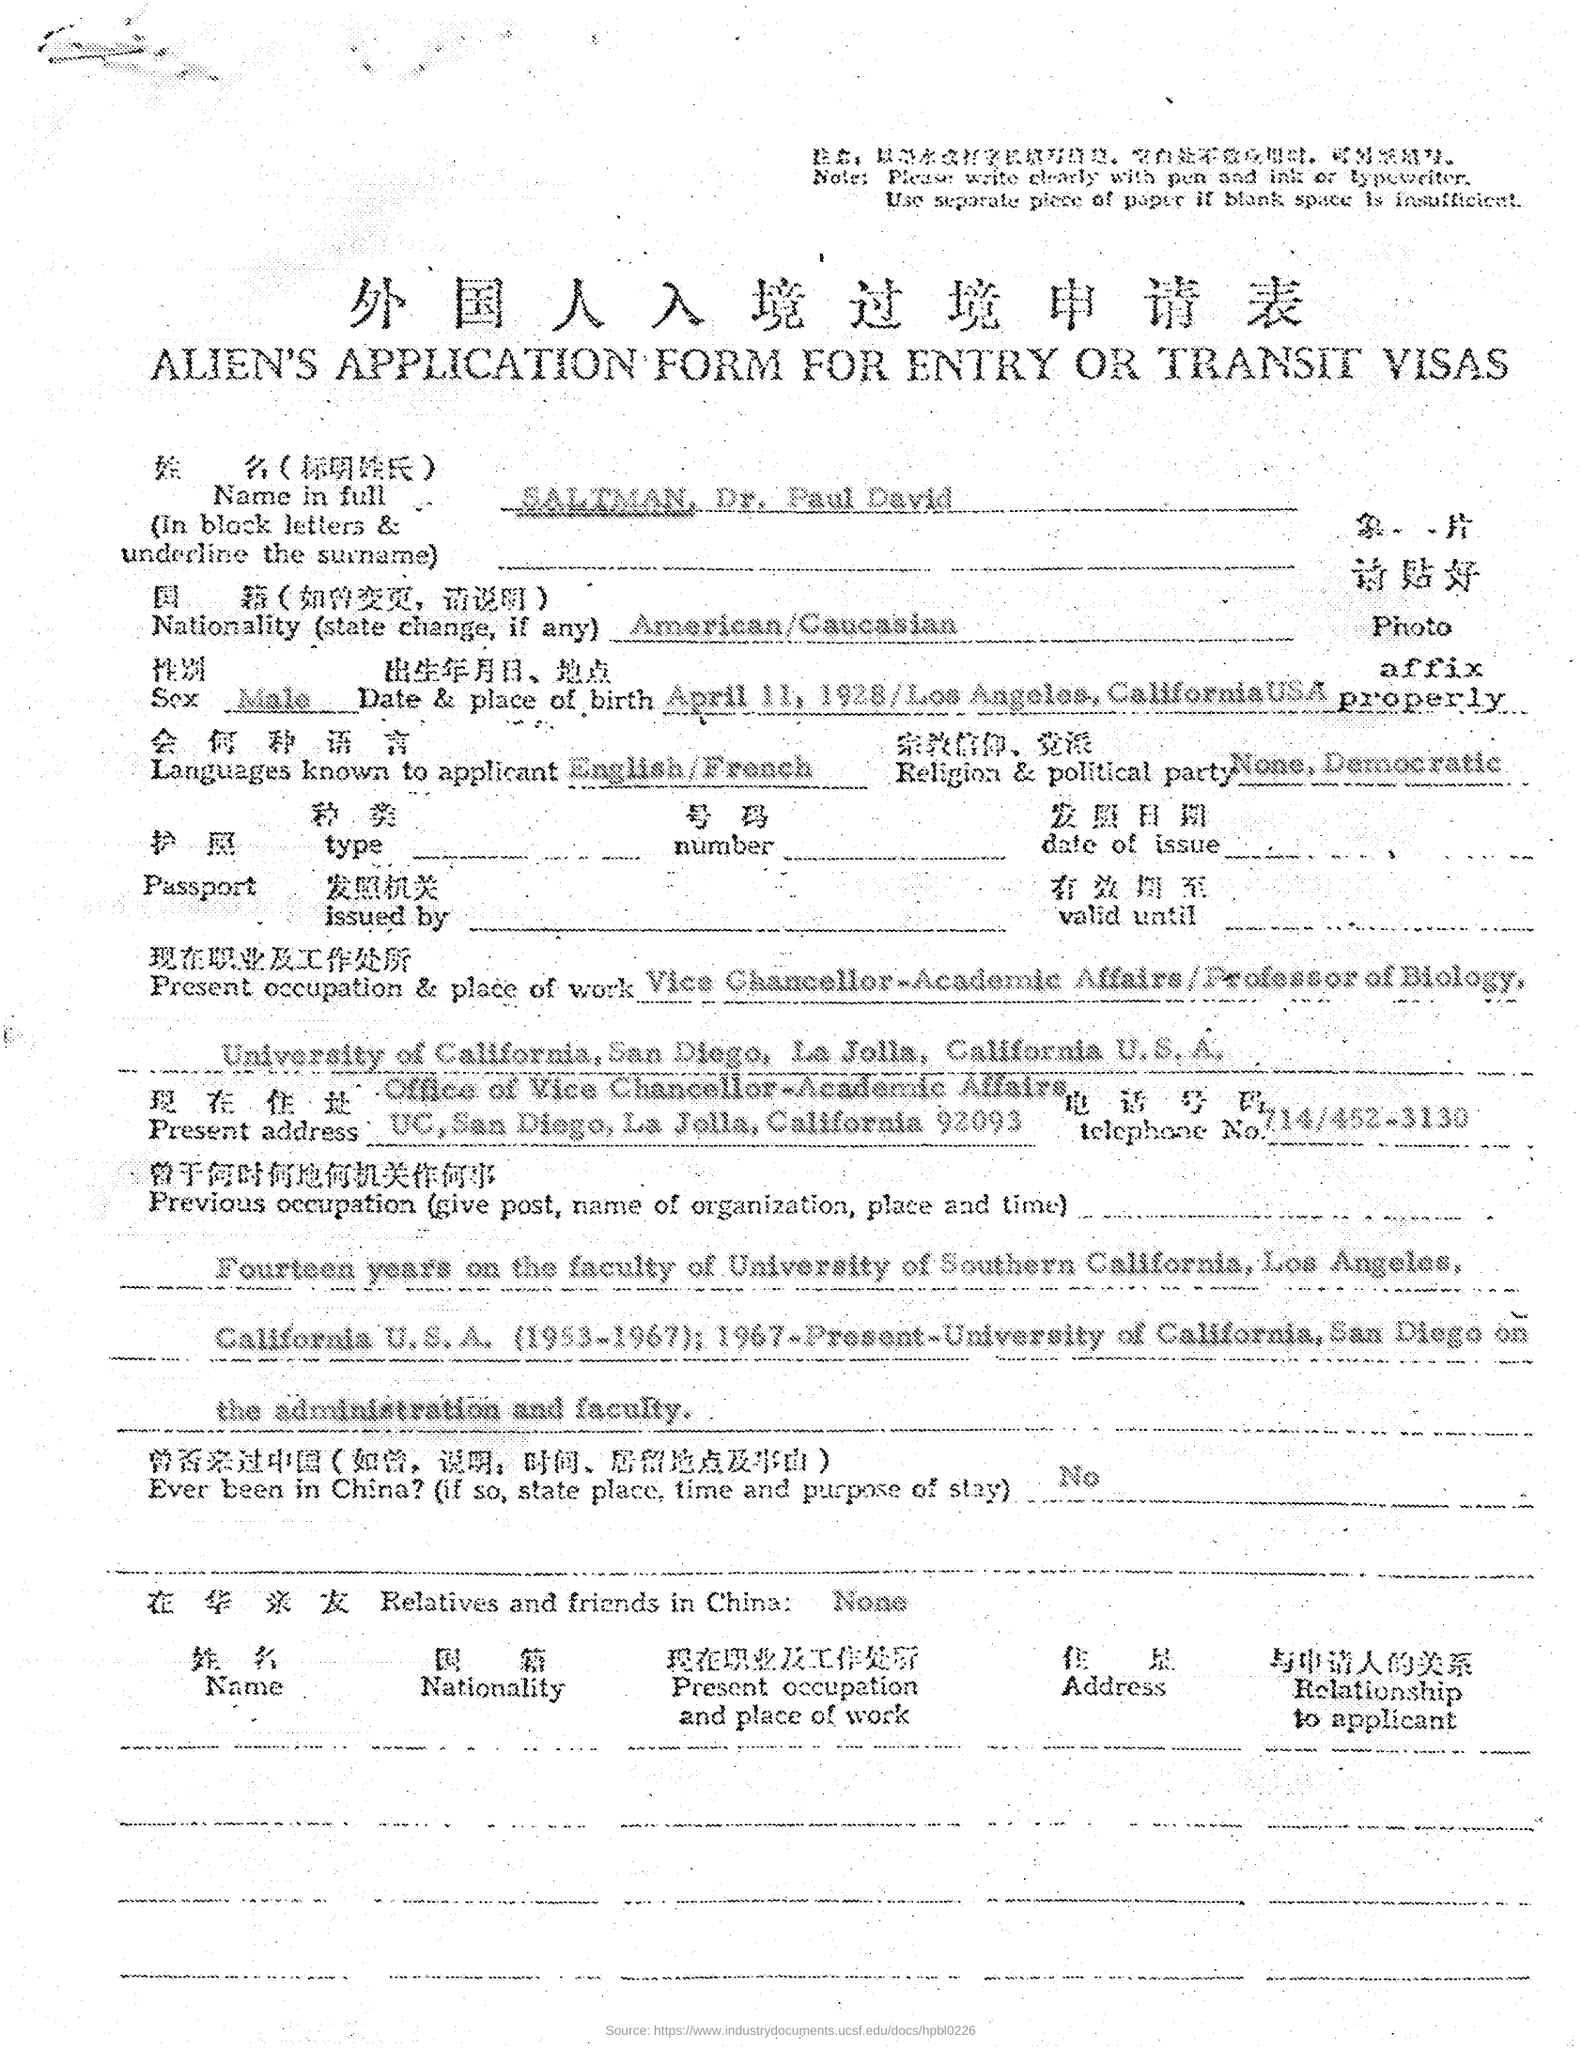What is the name mentioned in the application form?
Your answer should be compact. SALTMAN, Dr. Paul David. What is the Date of Birth of SALTMAN, Dr. Paul David?
Your answer should be very brief. April 11, 1928. What is the Telephone No of SALTMAN, Dr. Paul David mentioned in the application?
Provide a short and direct response. 714/452-3130. Has SALTMAN, Dr. Paul David ever been in China?
Keep it short and to the point. No. How many relatives and friends of  SALTMAN, Dr. Paul David was therein China?
Give a very brief answer. None. 